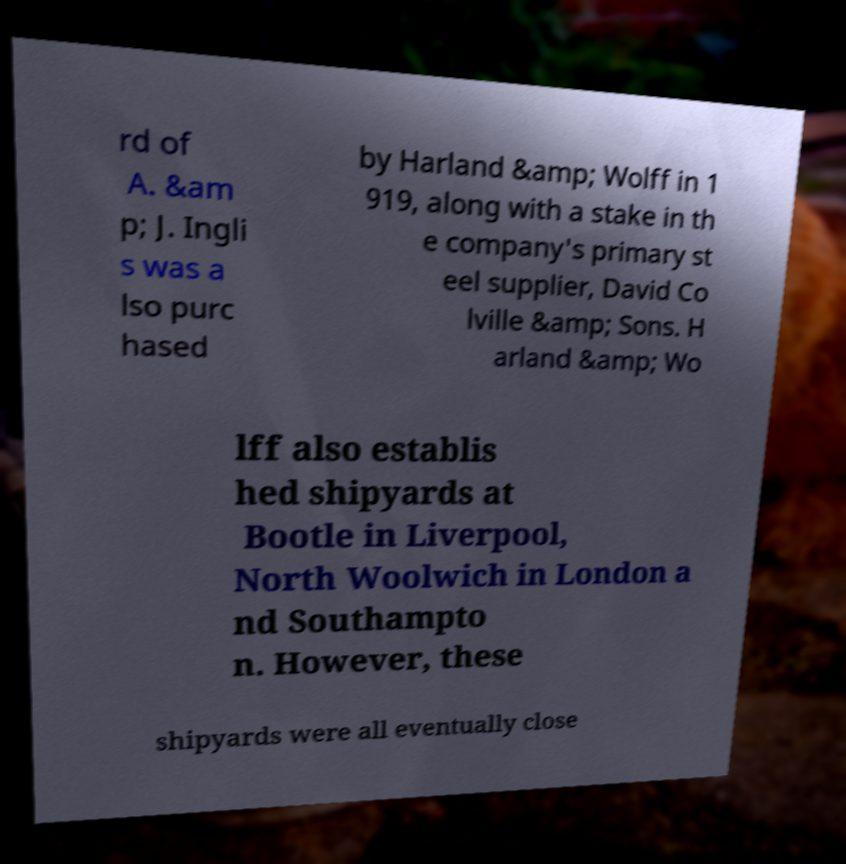For documentation purposes, I need the text within this image transcribed. Could you provide that? rd of A. &am p; J. Ingli s was a lso purc hased by Harland &amp; Wolff in 1 919, along with a stake in th e company's primary st eel supplier, David Co lville &amp; Sons. H arland &amp; Wo lff also establis hed shipyards at Bootle in Liverpool, North Woolwich in London a nd Southampto n. However, these shipyards were all eventually close 